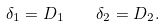Convert formula to latex. <formula><loc_0><loc_0><loc_500><loc_500>\delta _ { 1 } = D _ { 1 } \quad \delta _ { 2 } = D _ { 2 } .</formula> 